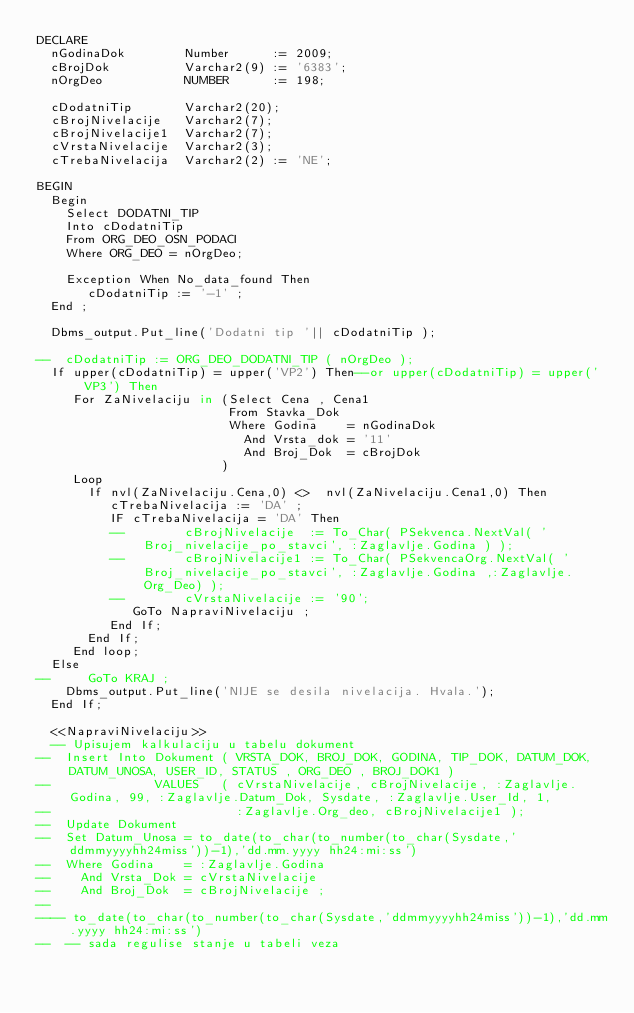<code> <loc_0><loc_0><loc_500><loc_500><_SQL_>DECLARE
  nGodinaDok        Number      := 2009;
  cBrojDok          Varchar2(9) := '6383';
  nOrgDeo           NUMBER      := 198;

  cDodatniTip       Varchar2(20);
  cBrojNivelacije   Varchar2(7);
  cBrojNivelacije1  Varchar2(7);
  cVrstaNivelacije  Varchar2(3);
  cTrebaNivelacija  Varchar2(2) := 'NE';

BEGIN
  Begin
    Select DODATNI_TIP
    Into cDodatniTip
    From ORG_DEO_OSN_PODACI
    Where ORG_DEO = nOrgDeo;

    Exception When No_data_found Then
       cDodatniTip := '-1' ;
  End ;

  Dbms_output.Put_line('Dodatni tip '|| cDodatniTip );

--  cDodatniTip := ORG_DEO_DODATNI_TIP ( nOrgDeo );
  If upper(cDodatniTip) = upper('VP2') Then--or upper(cDodatniTip) = upper('VP3') Then
     For ZaNivelaciju in (Select Cena , Cena1
                          From Stavka_Dok
                          Where Godina    = nGodinaDok
                            And Vrsta_dok = '11'
                            And Broj_Dok  = cBrojDok
                         )
     Loop
       If nvl(ZaNivelaciju.Cena,0) <>  nvl(ZaNivelaciju.Cena1,0) Then
          cTrebaNivelacija := 'DA' ;
          IF cTrebaNivelacija = 'DA' Then
          --        cBrojNivelacije  := To_Char( PSekvenca.NextVal( 'Broj_nivelacije_po_stavci', :Zaglavlje.Godina ) );
          --        cBrojNivelacije1 := To_Char( PSekvencaOrg.NextVal( 'Broj_nivelacije_po_stavci', :Zaglavlje.Godina ,:Zaglavlje.Org_Deo) );
          --        cVrstaNivelacije := '90';
             GoTo NapraviNivelaciju ;
          End If;
       End If;
     End loop;
  Else
--     GoTo KRAJ ;
    Dbms_output.Put_line('NIJE se desila nivelacija. Hvala.');
  End If;

  <<NapraviNivelaciju>>
  -- Upisujem kalkulaciju u tabelu dokument
--  Insert Into Dokument ( VRSTA_DOK, BROJ_DOK, GODINA, TIP_DOK, DATUM_DOK, DATUM_UNOSA, USER_ID, STATUS , ORG_DEO , BROJ_DOK1 )
--              VALUES   ( cVrstaNivelacije, cBrojNivelacije, :Zaglavlje.Godina, 99, :Zaglavlje.Datum_Dok, Sysdate, :Zaglavlje.User_Id, 1,
--                         :Zaglavlje.Org_deo, cBrojNivelacije1 );
--  Update Dokument
--  Set Datum_Unosa = to_date(to_char(to_number(to_char(Sysdate,'ddmmyyyyhh24miss'))-1),'dd.mm.yyyy hh24:mi:ss')
--  Where Godina    = :Zaglavlje.Godina
--    And Vrsta_Dok = cVrstaNivelacije
--    And Broj_Dok  = cBrojNivelacije ;
--
---- to_date(to_char(to_number(to_char(Sysdate,'ddmmyyyyhh24miss'))-1),'dd.mm.yyyy hh24:mi:ss')
--  -- sada regulise stanje u tabeli veza</code> 